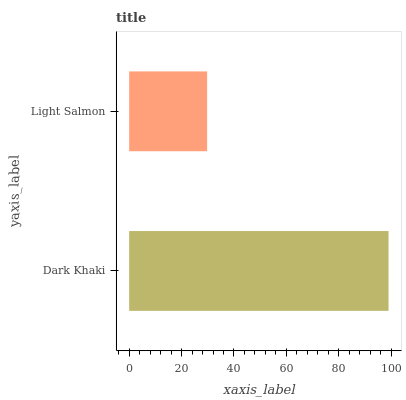Is Light Salmon the minimum?
Answer yes or no. Yes. Is Dark Khaki the maximum?
Answer yes or no. Yes. Is Light Salmon the maximum?
Answer yes or no. No. Is Dark Khaki greater than Light Salmon?
Answer yes or no. Yes. Is Light Salmon less than Dark Khaki?
Answer yes or no. Yes. Is Light Salmon greater than Dark Khaki?
Answer yes or no. No. Is Dark Khaki less than Light Salmon?
Answer yes or no. No. Is Dark Khaki the high median?
Answer yes or no. Yes. Is Light Salmon the low median?
Answer yes or no. Yes. Is Light Salmon the high median?
Answer yes or no. No. Is Dark Khaki the low median?
Answer yes or no. No. 